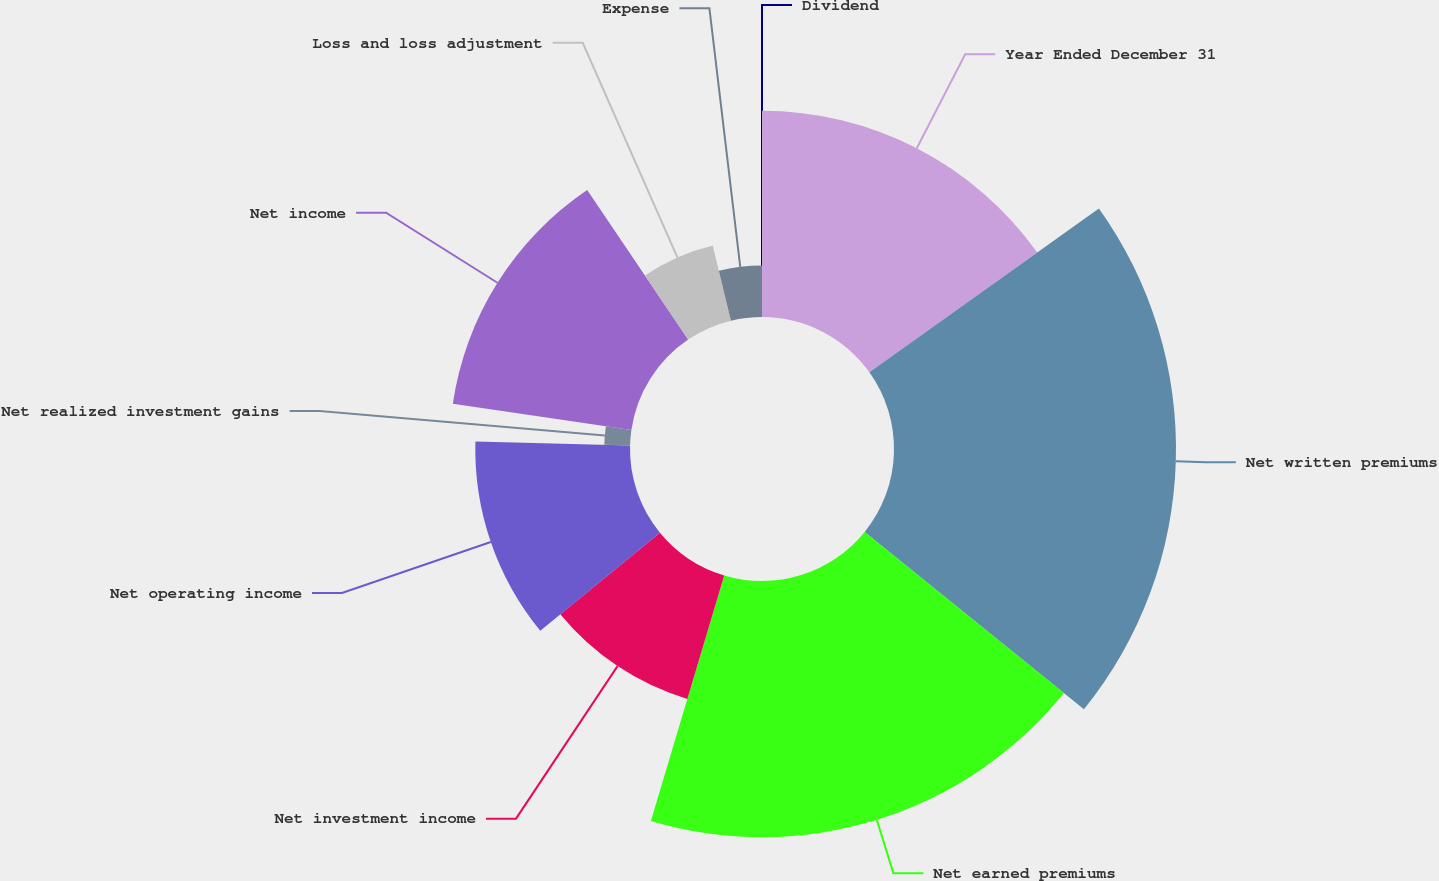Convert chart to OTSL. <chart><loc_0><loc_0><loc_500><loc_500><pie_chart><fcel>Year Ended December 31<fcel>Net written premiums<fcel>Net earned premiums<fcel>Net investment income<fcel>Net operating income<fcel>Net realized investment gains<fcel>Net income<fcel>Loss and loss adjustment<fcel>Expense<fcel>Dividend<nl><fcel>15.13%<fcel>20.69%<fcel>18.8%<fcel>9.45%<fcel>11.35%<fcel>1.89%<fcel>13.24%<fcel>5.67%<fcel>3.78%<fcel>0.0%<nl></chart> 